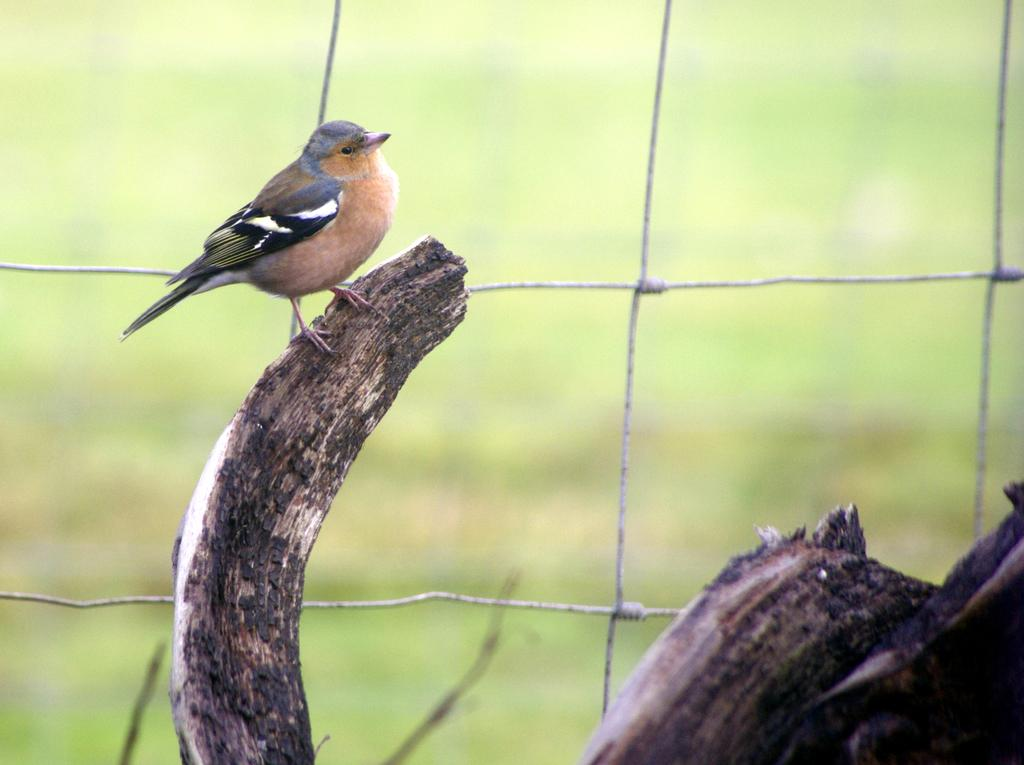What type of animal is in the image? There is a bird in the image. Where is the bird located in the image? The bird is on a stem. What else can be seen in the image? There is a fencing visible in the image. What type of linen is being used to clean the bird in the image? There is no linen or cleaning activity present in the image. Is there a doctor attending to the bird in the image? There is no doctor or medical attention depicted in the image. 